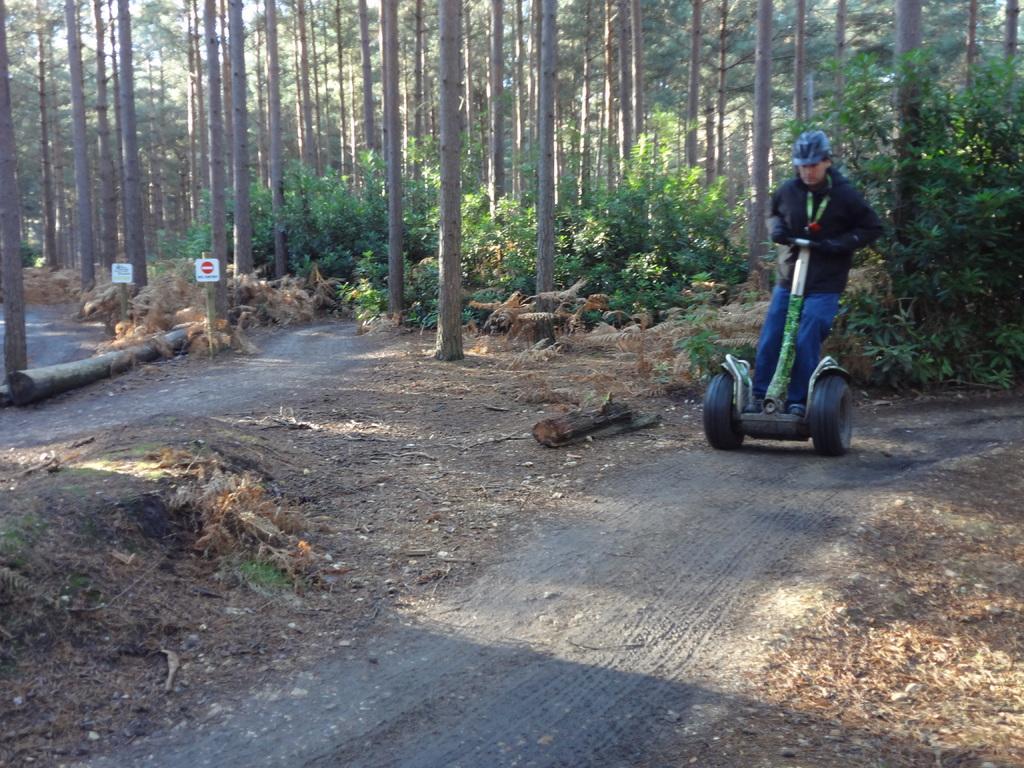How would you summarize this image in a sentence or two? This image consists of a person wearing black jacket and a helmet. Is moving on the cart. At the bottom, there is a road. In the background, there are trees. 